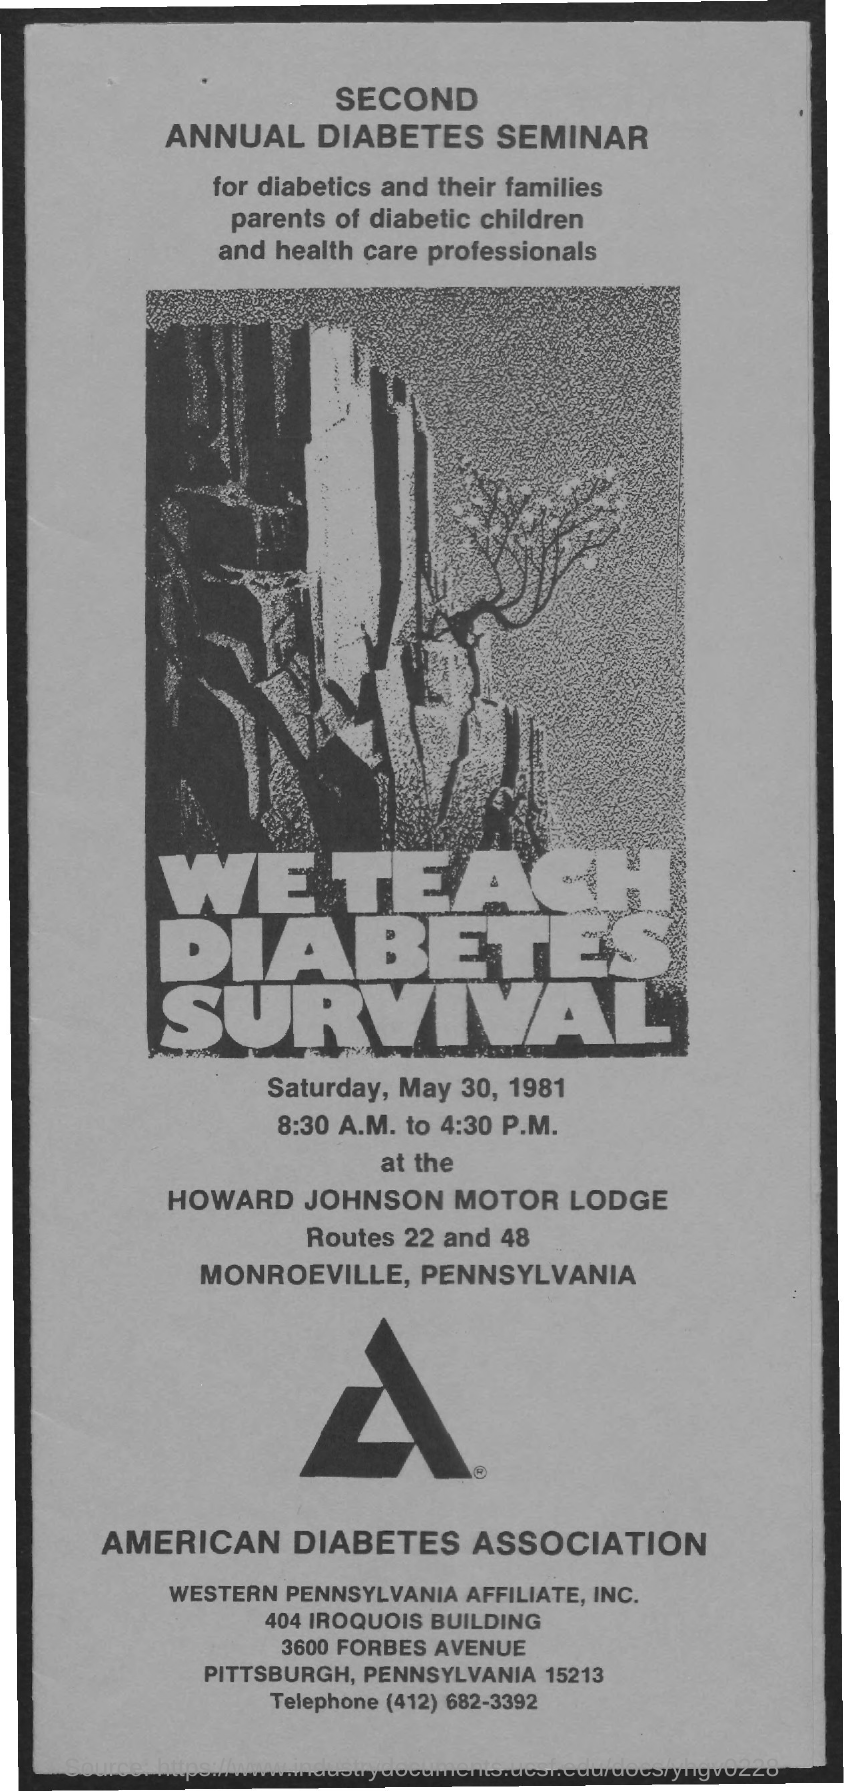What is the telephone number of western pennsylvania affiliate, inc.?
Ensure brevity in your answer.  (412) 682-3392. When will the seminar be held on?
Give a very brief answer. Saturday, May 30, 1981. 